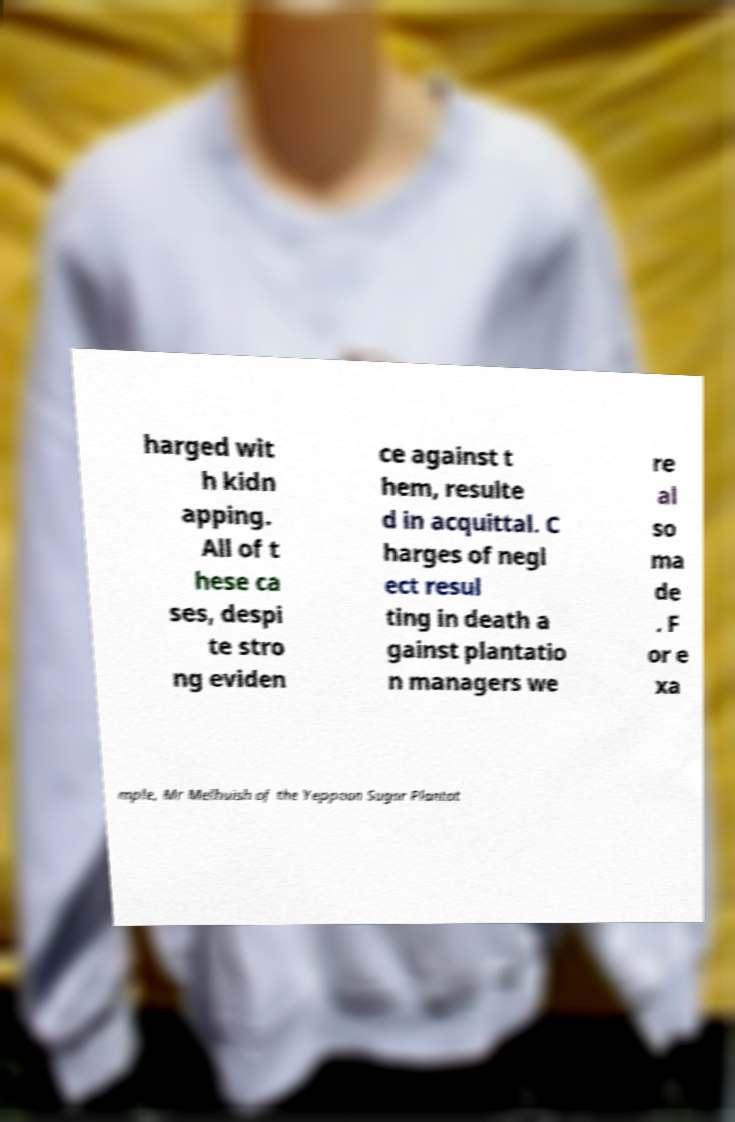Could you extract and type out the text from this image? harged wit h kidn apping. All of t hese ca ses, despi te stro ng eviden ce against t hem, resulte d in acquittal. C harges of negl ect resul ting in death a gainst plantatio n managers we re al so ma de . F or e xa mple, Mr Melhuish of the Yeppoon Sugar Plantat 